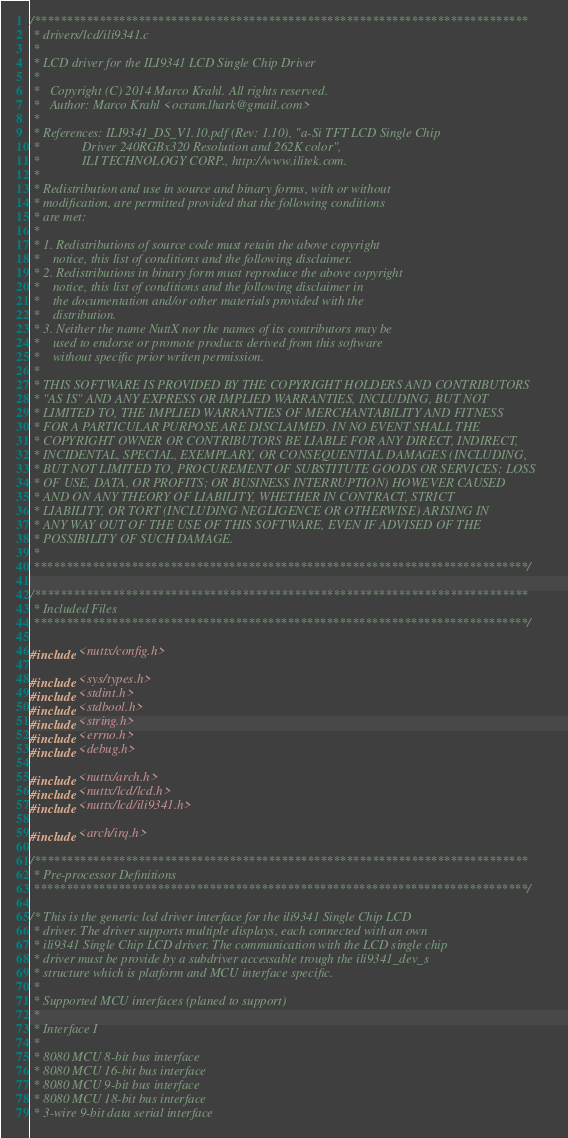Convert code to text. <code><loc_0><loc_0><loc_500><loc_500><_C_>/****************************************************************************
 * drivers/lcd/ili9341.c
 *
 * LCD driver for the ILI9341 LCD Single Chip Driver
 *
 *   Copyright (C) 2014 Marco Krahl. All rights reserved.
 *   Author: Marco Krahl <ocram.lhark@gmail.com>
 *
 * References: ILI9341_DS_V1.10.pdf (Rev: 1.10), "a-Si TFT LCD Single Chip
 *             Driver 240RGBx320 Resolution and 262K color",
 *             ILI TECHNOLOGY CORP., http://www.ilitek.com.
 *
 * Redistribution and use in source and binary forms, with or without
 * modification, are permitted provided that the following conditions
 * are met:
 *
 * 1. Redistributions of source code must retain the above copyright
 *    notice, this list of conditions and the following disclaimer.
 * 2. Redistributions in binary form must reproduce the above copyright
 *    notice, this list of conditions and the following disclaimer in
 *    the documentation and/or other materials provided with the
 *    distribution.
 * 3. Neither the name NuttX nor the names of its contributors may be
 *    used to endorse or promote products derived from this software
 *    without specific prior writen permission.
 *
 * THIS SOFTWARE IS PROVIDED BY THE COPYRIGHT HOLDERS AND CONTRIBUTORS
 * "AS IS" AND ANY EXPRESS OR IMPLIED WARRANTIES, INCLUDING, BUT NOT
 * LIMITED TO, THE IMPLIED WARRANTIES OF MERCHANTABILITY AND FITNESS
 * FOR A PARTICULAR PURPOSE ARE DISCLAIMED. IN NO EVENT SHALL THE
 * COPYRIGHT OWNER OR CONTRIBUTORS BE LIABLE FOR ANY DIRECT, INDIRECT,
 * INCIDENTAL, SPECIAL, EXEMPLARY, OR CONSEQUENTIAL DAMAGES (INCLUDING,
 * BUT NOT LIMITED TO, PROCUREMENT OF SUBSTITUTE GOODS OR SERVICES; LOSS
 * OF USE, DATA, OR PROFITS; OR BUSINESS INTERRUPTION) HOWEVER CAUSED
 * AND ON ANY THEORY OF LIABILITY, WHETHER IN CONTRACT, STRICT
 * LIABILITY, OR TORT (INCLUDING NEGLIGENCE OR OTHERWISE) ARISING IN
 * ANY WAY OUT OF THE USE OF THIS SOFTWARE, EVEN IF ADVISED OF THE
 * POSSIBILITY OF SUCH DAMAGE.
 *
 ****************************************************************************/

/****************************************************************************
 * Included Files
 ****************************************************************************/

#include <nuttx/config.h>

#include <sys/types.h>
#include <stdint.h>
#include <stdbool.h>
#include <string.h>
#include <errno.h>
#include <debug.h>

#include <nuttx/arch.h>
#include <nuttx/lcd/lcd.h>
#include <nuttx/lcd/ili9341.h>

#include <arch/irq.h>

/****************************************************************************
 * Pre-processor Definitions
 ****************************************************************************/

/* This is the generic lcd driver interface for the ili9341 Single Chip LCD
 * driver. The driver supports multiple displays, each connected with an own
 * ili9341 Single Chip LCD driver. The communication with the LCD single chip
 * driver must be provide by a subdriver accessable trough the ili9341_dev_s
 * structure which is platform and MCU interface specific.
 *
 * Supported MCU interfaces (planed to support)
 *
 * Interface I
 *
 * 8080 MCU 8-bit bus interface
 * 8080 MCU 16-bit bus interface
 * 8080 MCU 9-bit bus interface
 * 8080 MCU 18-bit bus interface
 * 3-wire 9-bit data serial interface</code> 